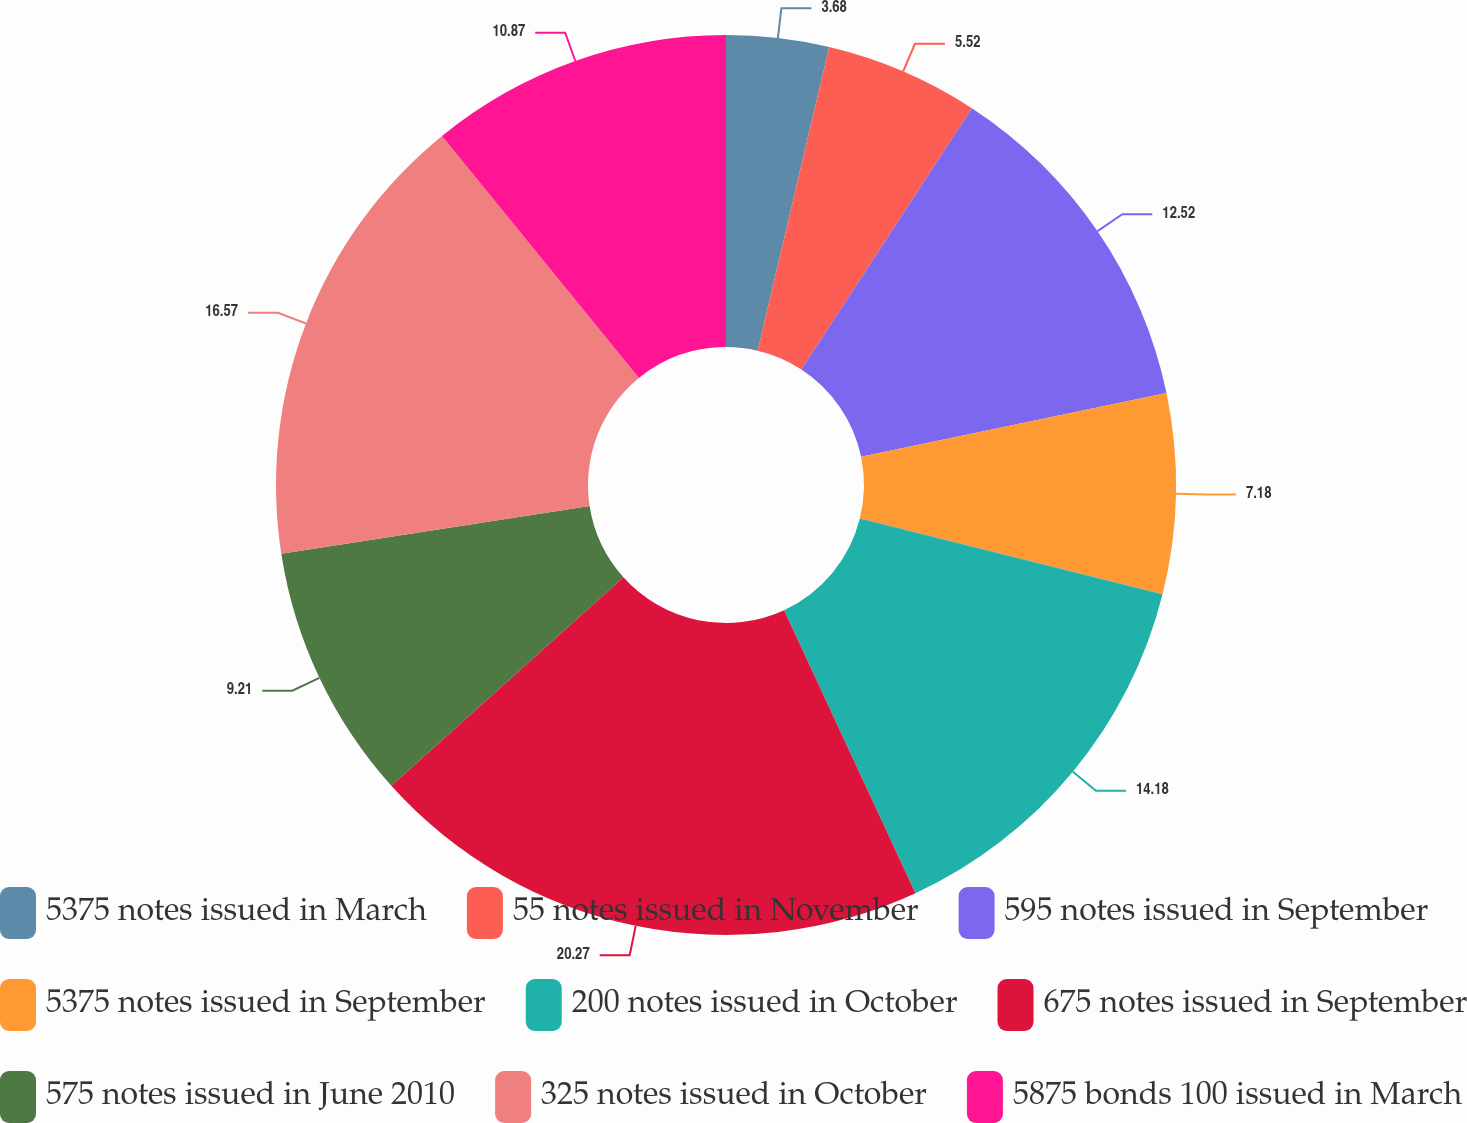Convert chart. <chart><loc_0><loc_0><loc_500><loc_500><pie_chart><fcel>5375 notes issued in March<fcel>55 notes issued in November<fcel>595 notes issued in September<fcel>5375 notes issued in September<fcel>200 notes issued in October<fcel>675 notes issued in September<fcel>575 notes issued in June 2010<fcel>325 notes issued in October<fcel>5875 bonds 100 issued in March<nl><fcel>3.68%<fcel>5.52%<fcel>12.52%<fcel>7.18%<fcel>14.18%<fcel>20.26%<fcel>9.21%<fcel>16.57%<fcel>10.87%<nl></chart> 